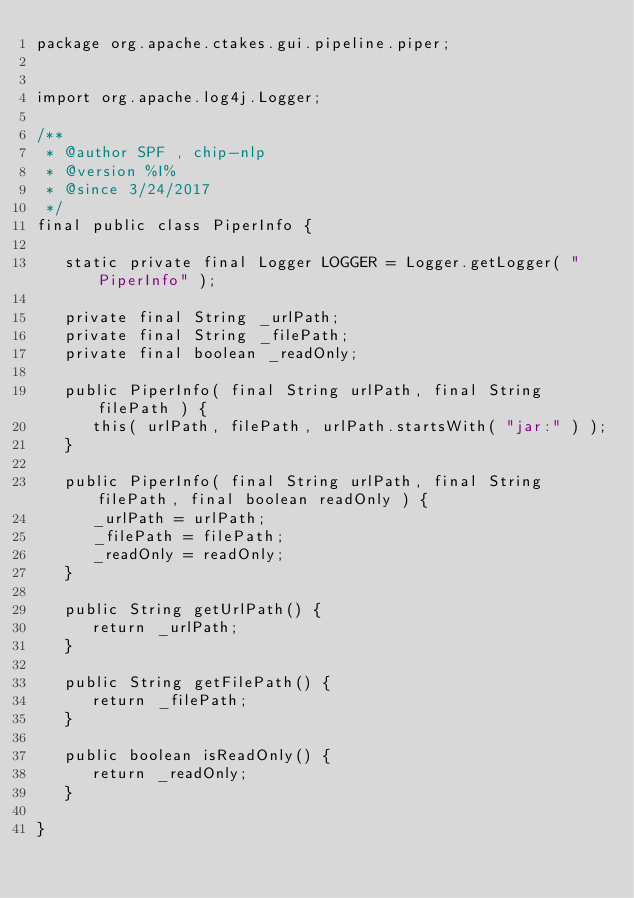Convert code to text. <code><loc_0><loc_0><loc_500><loc_500><_Java_>package org.apache.ctakes.gui.pipeline.piper;


import org.apache.log4j.Logger;

/**
 * @author SPF , chip-nlp
 * @version %I%
 * @since 3/24/2017
 */
final public class PiperInfo {

   static private final Logger LOGGER = Logger.getLogger( "PiperInfo" );

   private final String _urlPath;
   private final String _filePath;
   private final boolean _readOnly;

   public PiperInfo( final String urlPath, final String filePath ) {
      this( urlPath, filePath, urlPath.startsWith( "jar:" ) );
   }

   public PiperInfo( final String urlPath, final String filePath, final boolean readOnly ) {
      _urlPath = urlPath;
      _filePath = filePath;
      _readOnly = readOnly;
   }

   public String getUrlPath() {
      return _urlPath;
   }

   public String getFilePath() {
      return _filePath;
   }

   public boolean isReadOnly() {
      return _readOnly;
   }

}</code> 